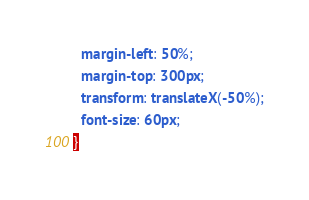Convert code to text. <code><loc_0><loc_0><loc_500><loc_500><_CSS_>  margin-left: 50%;
  margin-top: 300px;
  transform: translateX(-50%);
  font-size: 60px;
}
</code> 